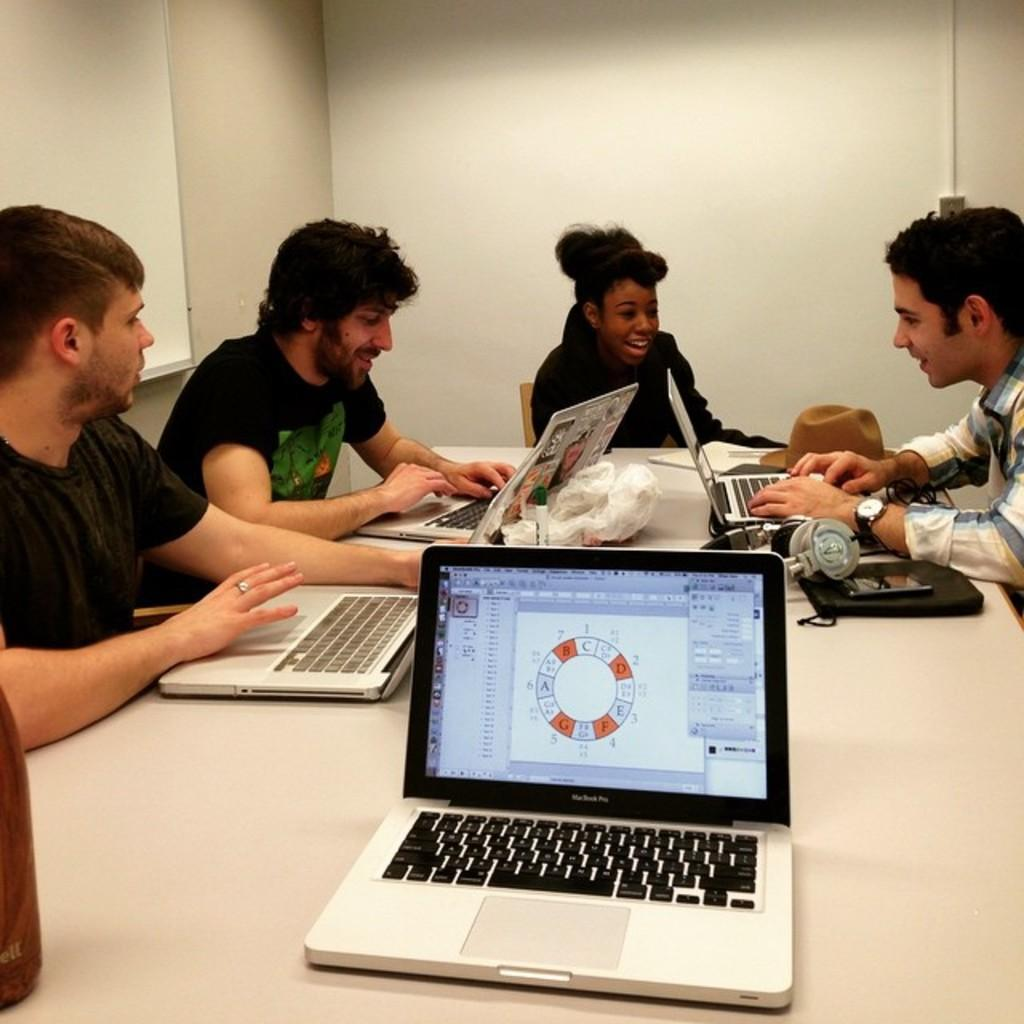What are the people in the image doing? People are sitting on chairs in the image. Where are the chairs located in relation to the table? The chairs are near a table in the image. What device is on the table? There is a laptop on the table in the image. What else can be seen on the table besides the laptop? Headphones are present on the table in the image. What type of bread is being used to control the laptop in the image? There is no bread present in the image, and bread is not used to control laptops. 